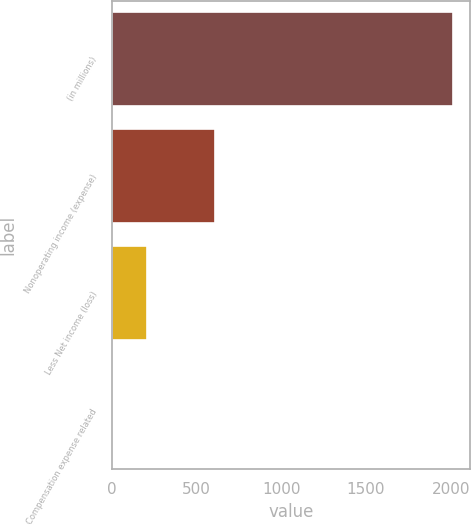Convert chart. <chart><loc_0><loc_0><loc_500><loc_500><bar_chart><fcel>(in millions)<fcel>Nonoperating income (expense)<fcel>Less Net income (loss)<fcel>Compensation expense related<nl><fcel>2012<fcel>607.8<fcel>206.6<fcel>6<nl></chart> 